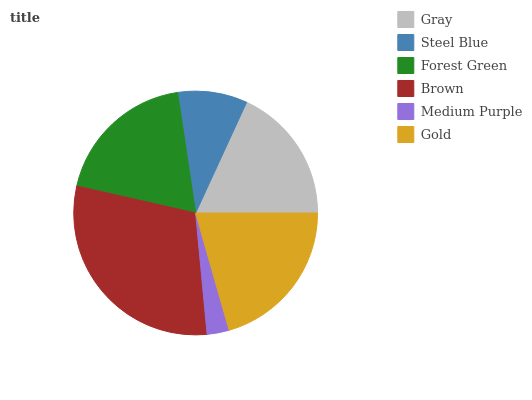Is Medium Purple the minimum?
Answer yes or no. Yes. Is Brown the maximum?
Answer yes or no. Yes. Is Steel Blue the minimum?
Answer yes or no. No. Is Steel Blue the maximum?
Answer yes or no. No. Is Gray greater than Steel Blue?
Answer yes or no. Yes. Is Steel Blue less than Gray?
Answer yes or no. Yes. Is Steel Blue greater than Gray?
Answer yes or no. No. Is Gray less than Steel Blue?
Answer yes or no. No. Is Forest Green the high median?
Answer yes or no. Yes. Is Gray the low median?
Answer yes or no. Yes. Is Steel Blue the high median?
Answer yes or no. No. Is Brown the low median?
Answer yes or no. No. 